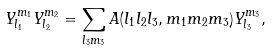<formula> <loc_0><loc_0><loc_500><loc_500>Y _ { l _ { 1 } } ^ { m _ { 1 } } Y _ { l _ { 2 } } ^ { m _ { 2 } } = \sum _ { l _ { 3 } m _ { 3 } } A ( l _ { 1 } l _ { 2 } l _ { 3 } , m _ { 1 } m _ { 2 } m _ { 3 } ) Y _ { l _ { 3 } } ^ { m _ { 3 } } ,</formula> 